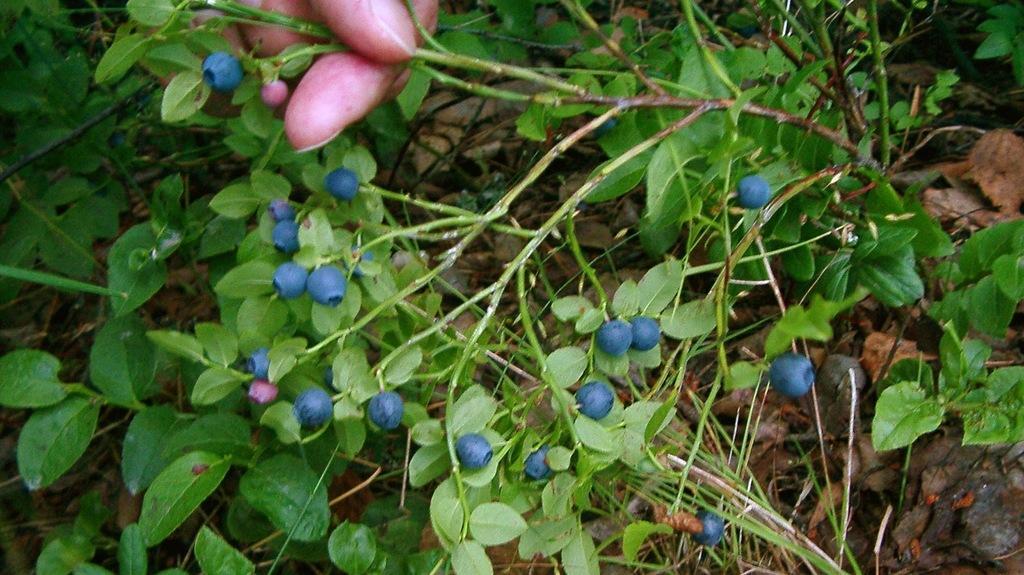Describe this image in one or two sentences. In this image we can see the hand of a person holding the stem of a plant containing some berries to it. We can also see some plants around it. 